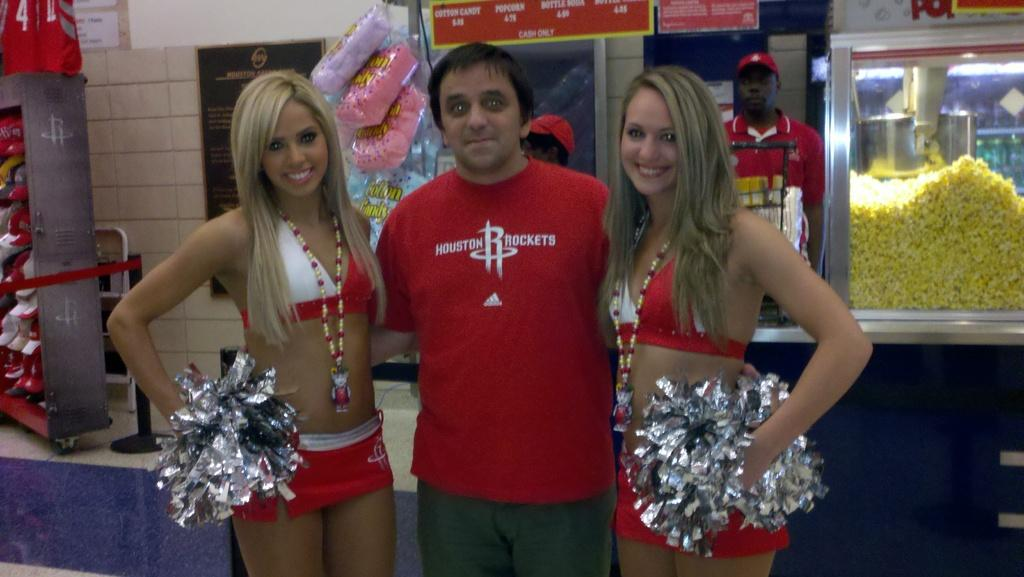<image>
Summarize the visual content of the image. Man wearing a Houston Rockets shirt taking a photo with cheerleaders. 